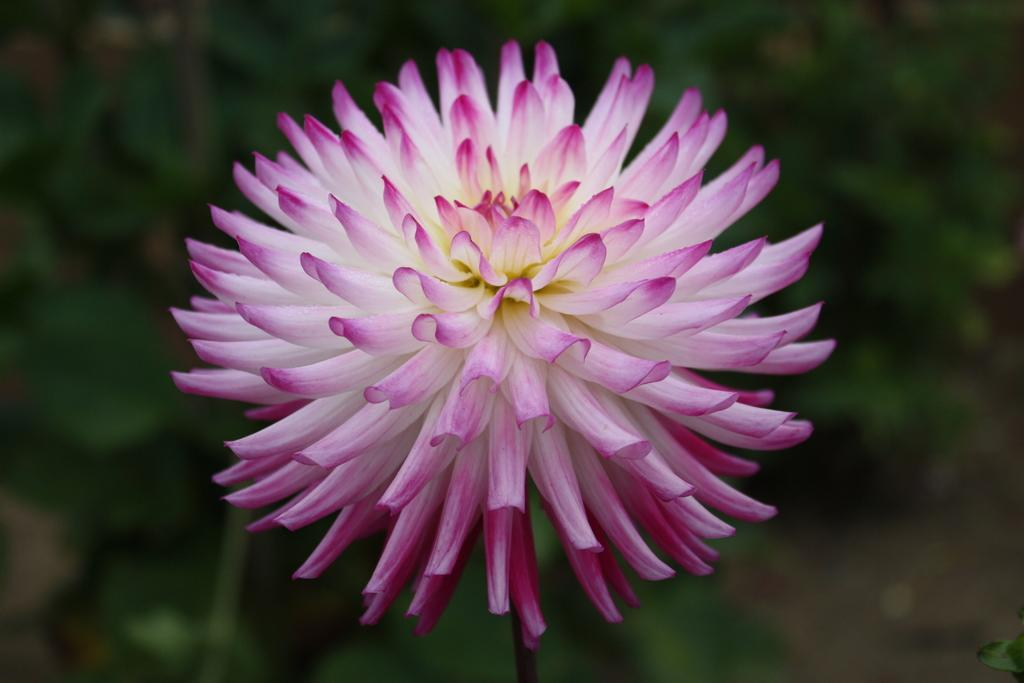What is the appearance of the flower in the image? The flower is beautiful. What colors can be seen on the flower? The flower has white and pink colors. What type of apparel is the flower wearing in the image? The flower is not wearing any apparel, as it is a natural object and not a person or an animal. Can you tell me what fact about the flower is not true? All the provided facts about the flower are true, so there is no false fact to identify. 